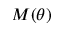<formula> <loc_0><loc_0><loc_500><loc_500>M ( \theta )</formula> 